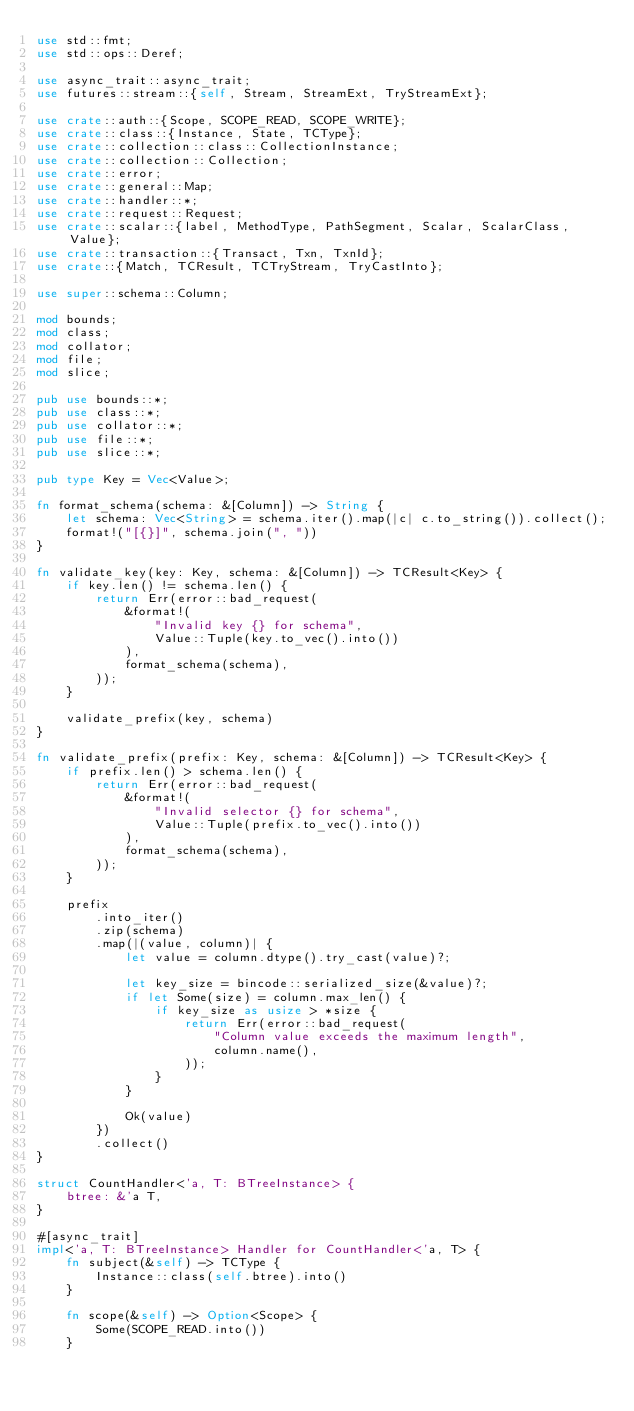Convert code to text. <code><loc_0><loc_0><loc_500><loc_500><_Rust_>use std::fmt;
use std::ops::Deref;

use async_trait::async_trait;
use futures::stream::{self, Stream, StreamExt, TryStreamExt};

use crate::auth::{Scope, SCOPE_READ, SCOPE_WRITE};
use crate::class::{Instance, State, TCType};
use crate::collection::class::CollectionInstance;
use crate::collection::Collection;
use crate::error;
use crate::general::Map;
use crate::handler::*;
use crate::request::Request;
use crate::scalar::{label, MethodType, PathSegment, Scalar, ScalarClass, Value};
use crate::transaction::{Transact, Txn, TxnId};
use crate::{Match, TCResult, TCTryStream, TryCastInto};

use super::schema::Column;

mod bounds;
mod class;
mod collator;
mod file;
mod slice;

pub use bounds::*;
pub use class::*;
pub use collator::*;
pub use file::*;
pub use slice::*;

pub type Key = Vec<Value>;

fn format_schema(schema: &[Column]) -> String {
    let schema: Vec<String> = schema.iter().map(|c| c.to_string()).collect();
    format!("[{}]", schema.join(", "))
}

fn validate_key(key: Key, schema: &[Column]) -> TCResult<Key> {
    if key.len() != schema.len() {
        return Err(error::bad_request(
            &format!(
                "Invalid key {} for schema",
                Value::Tuple(key.to_vec().into())
            ),
            format_schema(schema),
        ));
    }

    validate_prefix(key, schema)
}

fn validate_prefix(prefix: Key, schema: &[Column]) -> TCResult<Key> {
    if prefix.len() > schema.len() {
        return Err(error::bad_request(
            &format!(
                "Invalid selector {} for schema",
                Value::Tuple(prefix.to_vec().into())
            ),
            format_schema(schema),
        ));
    }

    prefix
        .into_iter()
        .zip(schema)
        .map(|(value, column)| {
            let value = column.dtype().try_cast(value)?;

            let key_size = bincode::serialized_size(&value)?;
            if let Some(size) = column.max_len() {
                if key_size as usize > *size {
                    return Err(error::bad_request(
                        "Column value exceeds the maximum length",
                        column.name(),
                    ));
                }
            }

            Ok(value)
        })
        .collect()
}

struct CountHandler<'a, T: BTreeInstance> {
    btree: &'a T,
}

#[async_trait]
impl<'a, T: BTreeInstance> Handler for CountHandler<'a, T> {
    fn subject(&self) -> TCType {
        Instance::class(self.btree).into()
    }

    fn scope(&self) -> Option<Scope> {
        Some(SCOPE_READ.into())
    }
</code> 